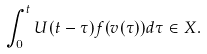<formula> <loc_0><loc_0><loc_500><loc_500>\int _ { 0 } ^ { t } U ( t - \tau ) f ( v ( \tau ) ) d \tau \in X .</formula> 